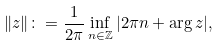Convert formula to latex. <formula><loc_0><loc_0><loc_500><loc_500>\| z \| \colon = \frac { 1 } { 2 \pi } \inf _ { n \in \mathbb { Z } } { | 2 \pi n + \arg z | } ,</formula> 